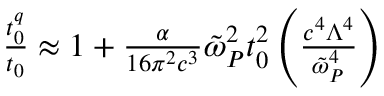Convert formula to latex. <formula><loc_0><loc_0><loc_500><loc_500>\begin{array} { r } { \frac { t _ { 0 } ^ { q } } { t _ { 0 } } \approx 1 + \frac { \alpha } { 1 6 \pi ^ { 2 } c ^ { 3 } } \tilde { \omega } _ { P } ^ { 2 } t _ { 0 } ^ { 2 } \left ( \frac { c ^ { 4 } \Lambda ^ { 4 } } { \tilde { \omega } _ { P } ^ { 4 } } \right ) } \end{array}</formula> 